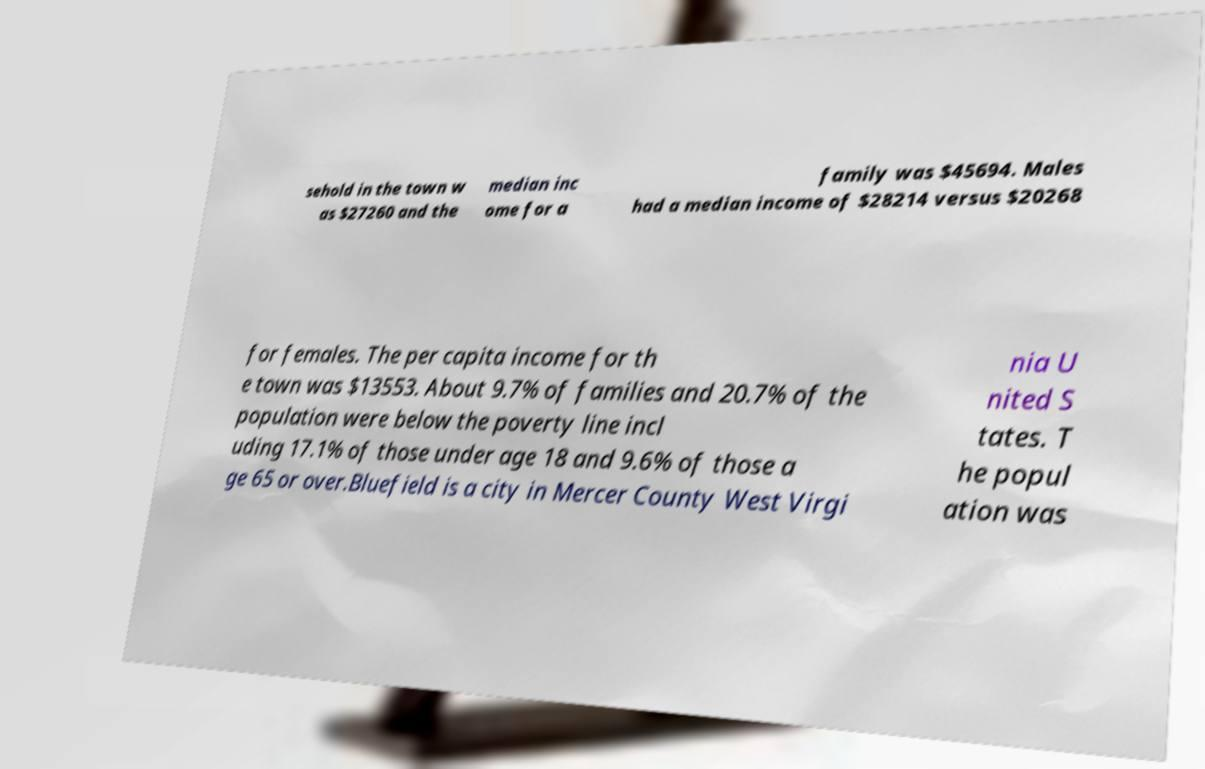I need the written content from this picture converted into text. Can you do that? sehold in the town w as $27260 and the median inc ome for a family was $45694. Males had a median income of $28214 versus $20268 for females. The per capita income for th e town was $13553. About 9.7% of families and 20.7% of the population were below the poverty line incl uding 17.1% of those under age 18 and 9.6% of those a ge 65 or over.Bluefield is a city in Mercer County West Virgi nia U nited S tates. T he popul ation was 